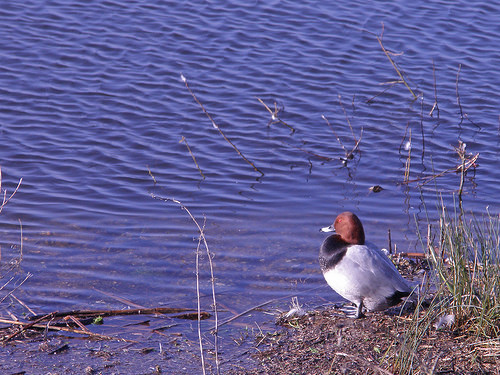<image>
Is the duck in the water? No. The duck is not contained within the water. These objects have a different spatial relationship. 